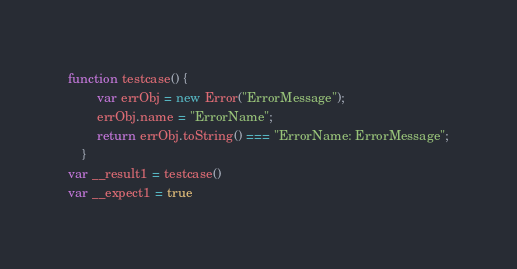Convert code to text. <code><loc_0><loc_0><loc_500><loc_500><_JavaScript_>function testcase() {
        var errObj = new Error("ErrorMessage");
        errObj.name = "ErrorName";
        return errObj.toString() === "ErrorName: ErrorMessage";
    }
var __result1 = testcase()
var __expect1 = true
</code> 